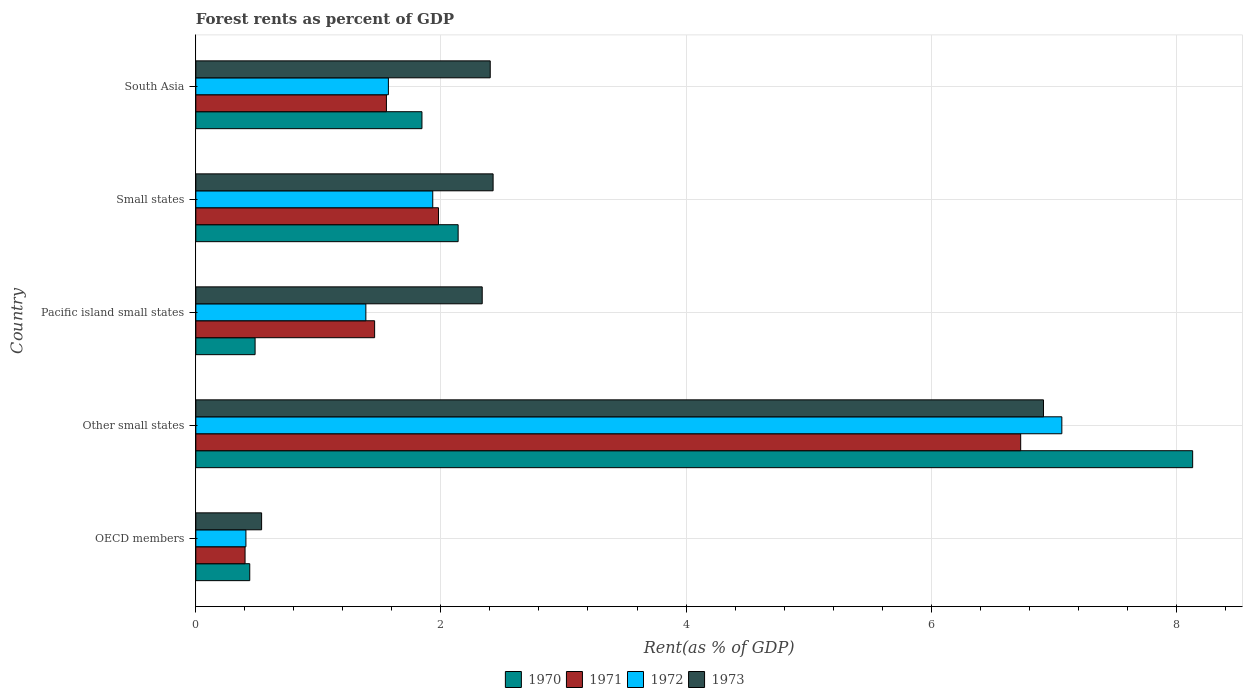How many groups of bars are there?
Your answer should be compact. 5. How many bars are there on the 1st tick from the top?
Make the answer very short. 4. How many bars are there on the 4th tick from the bottom?
Your answer should be compact. 4. What is the label of the 4th group of bars from the top?
Provide a short and direct response. Other small states. What is the forest rent in 1971 in South Asia?
Provide a short and direct response. 1.56. Across all countries, what is the maximum forest rent in 1970?
Your response must be concise. 8.13. Across all countries, what is the minimum forest rent in 1971?
Provide a short and direct response. 0.4. In which country was the forest rent in 1972 maximum?
Your answer should be compact. Other small states. What is the total forest rent in 1970 in the graph?
Make the answer very short. 13.04. What is the difference between the forest rent in 1970 in Other small states and that in Small states?
Make the answer very short. 5.99. What is the difference between the forest rent in 1971 in South Asia and the forest rent in 1970 in OECD members?
Your answer should be very brief. 1.12. What is the average forest rent in 1972 per country?
Provide a short and direct response. 2.47. What is the difference between the forest rent in 1971 and forest rent in 1972 in South Asia?
Your answer should be very brief. -0.02. What is the ratio of the forest rent in 1972 in Pacific island small states to that in South Asia?
Make the answer very short. 0.88. Is the forest rent in 1972 in Other small states less than that in South Asia?
Make the answer very short. No. What is the difference between the highest and the second highest forest rent in 1972?
Offer a terse response. 5.13. What is the difference between the highest and the lowest forest rent in 1972?
Give a very brief answer. 6.66. Is the sum of the forest rent in 1972 in Other small states and South Asia greater than the maximum forest rent in 1973 across all countries?
Your answer should be very brief. Yes. Is it the case that in every country, the sum of the forest rent in 1972 and forest rent in 1971 is greater than the sum of forest rent in 1973 and forest rent in 1970?
Offer a very short reply. No. What does the 4th bar from the top in South Asia represents?
Give a very brief answer. 1970. What does the 2nd bar from the bottom in South Asia represents?
Your response must be concise. 1971. What is the difference between two consecutive major ticks on the X-axis?
Provide a short and direct response. 2. Does the graph contain any zero values?
Offer a very short reply. No. Does the graph contain grids?
Give a very brief answer. Yes. How many legend labels are there?
Keep it short and to the point. 4. How are the legend labels stacked?
Provide a short and direct response. Horizontal. What is the title of the graph?
Provide a succinct answer. Forest rents as percent of GDP. What is the label or title of the X-axis?
Your answer should be compact. Rent(as % of GDP). What is the label or title of the Y-axis?
Give a very brief answer. Country. What is the Rent(as % of GDP) of 1970 in OECD members?
Your response must be concise. 0.44. What is the Rent(as % of GDP) in 1971 in OECD members?
Your answer should be compact. 0.4. What is the Rent(as % of GDP) of 1972 in OECD members?
Provide a succinct answer. 0.41. What is the Rent(as % of GDP) in 1973 in OECD members?
Provide a succinct answer. 0.54. What is the Rent(as % of GDP) of 1970 in Other small states?
Keep it short and to the point. 8.13. What is the Rent(as % of GDP) in 1971 in Other small states?
Your answer should be compact. 6.73. What is the Rent(as % of GDP) in 1972 in Other small states?
Offer a very short reply. 7.07. What is the Rent(as % of GDP) of 1973 in Other small states?
Offer a terse response. 6.92. What is the Rent(as % of GDP) in 1970 in Pacific island small states?
Offer a terse response. 0.48. What is the Rent(as % of GDP) in 1971 in Pacific island small states?
Your answer should be very brief. 1.46. What is the Rent(as % of GDP) in 1972 in Pacific island small states?
Ensure brevity in your answer.  1.39. What is the Rent(as % of GDP) of 1973 in Pacific island small states?
Your answer should be very brief. 2.34. What is the Rent(as % of GDP) of 1970 in Small states?
Provide a short and direct response. 2.14. What is the Rent(as % of GDP) of 1971 in Small states?
Ensure brevity in your answer.  1.98. What is the Rent(as % of GDP) of 1972 in Small states?
Keep it short and to the point. 1.93. What is the Rent(as % of GDP) of 1973 in Small states?
Your answer should be very brief. 2.43. What is the Rent(as % of GDP) of 1970 in South Asia?
Offer a terse response. 1.85. What is the Rent(as % of GDP) of 1971 in South Asia?
Offer a terse response. 1.56. What is the Rent(as % of GDP) in 1972 in South Asia?
Your answer should be very brief. 1.57. What is the Rent(as % of GDP) in 1973 in South Asia?
Your answer should be compact. 2.4. Across all countries, what is the maximum Rent(as % of GDP) of 1970?
Your answer should be very brief. 8.13. Across all countries, what is the maximum Rent(as % of GDP) of 1971?
Make the answer very short. 6.73. Across all countries, what is the maximum Rent(as % of GDP) in 1972?
Make the answer very short. 7.07. Across all countries, what is the maximum Rent(as % of GDP) in 1973?
Your answer should be compact. 6.92. Across all countries, what is the minimum Rent(as % of GDP) in 1970?
Offer a very short reply. 0.44. Across all countries, what is the minimum Rent(as % of GDP) of 1971?
Give a very brief answer. 0.4. Across all countries, what is the minimum Rent(as % of GDP) of 1972?
Your response must be concise. 0.41. Across all countries, what is the minimum Rent(as % of GDP) in 1973?
Offer a very short reply. 0.54. What is the total Rent(as % of GDP) in 1970 in the graph?
Provide a succinct answer. 13.04. What is the total Rent(as % of GDP) of 1971 in the graph?
Offer a terse response. 12.13. What is the total Rent(as % of GDP) in 1972 in the graph?
Make the answer very short. 12.37. What is the total Rent(as % of GDP) in 1973 in the graph?
Keep it short and to the point. 14.62. What is the difference between the Rent(as % of GDP) of 1970 in OECD members and that in Other small states?
Your answer should be very brief. -7.69. What is the difference between the Rent(as % of GDP) of 1971 in OECD members and that in Other small states?
Provide a short and direct response. -6.33. What is the difference between the Rent(as % of GDP) of 1972 in OECD members and that in Other small states?
Offer a terse response. -6.66. What is the difference between the Rent(as % of GDP) of 1973 in OECD members and that in Other small states?
Keep it short and to the point. -6.38. What is the difference between the Rent(as % of GDP) of 1970 in OECD members and that in Pacific island small states?
Offer a terse response. -0.04. What is the difference between the Rent(as % of GDP) in 1971 in OECD members and that in Pacific island small states?
Keep it short and to the point. -1.06. What is the difference between the Rent(as % of GDP) in 1972 in OECD members and that in Pacific island small states?
Provide a succinct answer. -0.98. What is the difference between the Rent(as % of GDP) of 1973 in OECD members and that in Pacific island small states?
Your answer should be very brief. -1.8. What is the difference between the Rent(as % of GDP) of 1970 in OECD members and that in Small states?
Your response must be concise. -1.7. What is the difference between the Rent(as % of GDP) in 1971 in OECD members and that in Small states?
Offer a terse response. -1.58. What is the difference between the Rent(as % of GDP) in 1972 in OECD members and that in Small states?
Your answer should be very brief. -1.52. What is the difference between the Rent(as % of GDP) of 1973 in OECD members and that in Small states?
Offer a terse response. -1.89. What is the difference between the Rent(as % of GDP) of 1970 in OECD members and that in South Asia?
Provide a short and direct response. -1.41. What is the difference between the Rent(as % of GDP) of 1971 in OECD members and that in South Asia?
Offer a very short reply. -1.15. What is the difference between the Rent(as % of GDP) in 1972 in OECD members and that in South Asia?
Offer a terse response. -1.16. What is the difference between the Rent(as % of GDP) in 1973 in OECD members and that in South Asia?
Your answer should be very brief. -1.87. What is the difference between the Rent(as % of GDP) of 1970 in Other small states and that in Pacific island small states?
Your response must be concise. 7.65. What is the difference between the Rent(as % of GDP) of 1971 in Other small states and that in Pacific island small states?
Your answer should be very brief. 5.27. What is the difference between the Rent(as % of GDP) in 1972 in Other small states and that in Pacific island small states?
Provide a short and direct response. 5.68. What is the difference between the Rent(as % of GDP) in 1973 in Other small states and that in Pacific island small states?
Provide a short and direct response. 4.58. What is the difference between the Rent(as % of GDP) of 1970 in Other small states and that in Small states?
Keep it short and to the point. 5.99. What is the difference between the Rent(as % of GDP) of 1971 in Other small states and that in Small states?
Give a very brief answer. 4.75. What is the difference between the Rent(as % of GDP) in 1972 in Other small states and that in Small states?
Keep it short and to the point. 5.13. What is the difference between the Rent(as % of GDP) of 1973 in Other small states and that in Small states?
Give a very brief answer. 4.49. What is the difference between the Rent(as % of GDP) of 1970 in Other small states and that in South Asia?
Your answer should be very brief. 6.29. What is the difference between the Rent(as % of GDP) of 1971 in Other small states and that in South Asia?
Offer a terse response. 5.18. What is the difference between the Rent(as % of GDP) of 1972 in Other small states and that in South Asia?
Make the answer very short. 5.5. What is the difference between the Rent(as % of GDP) of 1973 in Other small states and that in South Asia?
Ensure brevity in your answer.  4.51. What is the difference between the Rent(as % of GDP) of 1970 in Pacific island small states and that in Small states?
Make the answer very short. -1.66. What is the difference between the Rent(as % of GDP) of 1971 in Pacific island small states and that in Small states?
Give a very brief answer. -0.52. What is the difference between the Rent(as % of GDP) of 1972 in Pacific island small states and that in Small states?
Provide a succinct answer. -0.55. What is the difference between the Rent(as % of GDP) in 1973 in Pacific island small states and that in Small states?
Ensure brevity in your answer.  -0.09. What is the difference between the Rent(as % of GDP) of 1970 in Pacific island small states and that in South Asia?
Keep it short and to the point. -1.36. What is the difference between the Rent(as % of GDP) of 1971 in Pacific island small states and that in South Asia?
Your answer should be very brief. -0.1. What is the difference between the Rent(as % of GDP) of 1972 in Pacific island small states and that in South Asia?
Provide a succinct answer. -0.18. What is the difference between the Rent(as % of GDP) of 1973 in Pacific island small states and that in South Asia?
Your response must be concise. -0.07. What is the difference between the Rent(as % of GDP) of 1970 in Small states and that in South Asia?
Make the answer very short. 0.3. What is the difference between the Rent(as % of GDP) of 1971 in Small states and that in South Asia?
Provide a short and direct response. 0.42. What is the difference between the Rent(as % of GDP) in 1972 in Small states and that in South Asia?
Your answer should be compact. 0.36. What is the difference between the Rent(as % of GDP) of 1973 in Small states and that in South Asia?
Your response must be concise. 0.02. What is the difference between the Rent(as % of GDP) in 1970 in OECD members and the Rent(as % of GDP) in 1971 in Other small states?
Provide a short and direct response. -6.29. What is the difference between the Rent(as % of GDP) in 1970 in OECD members and the Rent(as % of GDP) in 1972 in Other small states?
Keep it short and to the point. -6.63. What is the difference between the Rent(as % of GDP) of 1970 in OECD members and the Rent(as % of GDP) of 1973 in Other small states?
Provide a succinct answer. -6.48. What is the difference between the Rent(as % of GDP) in 1971 in OECD members and the Rent(as % of GDP) in 1972 in Other small states?
Your answer should be compact. -6.67. What is the difference between the Rent(as % of GDP) of 1971 in OECD members and the Rent(as % of GDP) of 1973 in Other small states?
Give a very brief answer. -6.52. What is the difference between the Rent(as % of GDP) of 1972 in OECD members and the Rent(as % of GDP) of 1973 in Other small states?
Your response must be concise. -6.51. What is the difference between the Rent(as % of GDP) of 1970 in OECD members and the Rent(as % of GDP) of 1971 in Pacific island small states?
Provide a succinct answer. -1.02. What is the difference between the Rent(as % of GDP) of 1970 in OECD members and the Rent(as % of GDP) of 1972 in Pacific island small states?
Your response must be concise. -0.95. What is the difference between the Rent(as % of GDP) in 1970 in OECD members and the Rent(as % of GDP) in 1973 in Pacific island small states?
Offer a very short reply. -1.9. What is the difference between the Rent(as % of GDP) in 1971 in OECD members and the Rent(as % of GDP) in 1972 in Pacific island small states?
Make the answer very short. -0.99. What is the difference between the Rent(as % of GDP) of 1971 in OECD members and the Rent(as % of GDP) of 1973 in Pacific island small states?
Provide a succinct answer. -1.94. What is the difference between the Rent(as % of GDP) of 1972 in OECD members and the Rent(as % of GDP) of 1973 in Pacific island small states?
Provide a short and direct response. -1.93. What is the difference between the Rent(as % of GDP) in 1970 in OECD members and the Rent(as % of GDP) in 1971 in Small states?
Keep it short and to the point. -1.54. What is the difference between the Rent(as % of GDP) of 1970 in OECD members and the Rent(as % of GDP) of 1972 in Small states?
Your answer should be very brief. -1.49. What is the difference between the Rent(as % of GDP) of 1970 in OECD members and the Rent(as % of GDP) of 1973 in Small states?
Give a very brief answer. -1.99. What is the difference between the Rent(as % of GDP) of 1971 in OECD members and the Rent(as % of GDP) of 1972 in Small states?
Your answer should be very brief. -1.53. What is the difference between the Rent(as % of GDP) in 1971 in OECD members and the Rent(as % of GDP) in 1973 in Small states?
Provide a succinct answer. -2.02. What is the difference between the Rent(as % of GDP) of 1972 in OECD members and the Rent(as % of GDP) of 1973 in Small states?
Keep it short and to the point. -2.02. What is the difference between the Rent(as % of GDP) of 1970 in OECD members and the Rent(as % of GDP) of 1971 in South Asia?
Keep it short and to the point. -1.12. What is the difference between the Rent(as % of GDP) in 1970 in OECD members and the Rent(as % of GDP) in 1972 in South Asia?
Give a very brief answer. -1.13. What is the difference between the Rent(as % of GDP) in 1970 in OECD members and the Rent(as % of GDP) in 1973 in South Asia?
Provide a short and direct response. -1.96. What is the difference between the Rent(as % of GDP) of 1971 in OECD members and the Rent(as % of GDP) of 1972 in South Asia?
Offer a terse response. -1.17. What is the difference between the Rent(as % of GDP) of 1971 in OECD members and the Rent(as % of GDP) of 1973 in South Asia?
Keep it short and to the point. -2. What is the difference between the Rent(as % of GDP) of 1972 in OECD members and the Rent(as % of GDP) of 1973 in South Asia?
Give a very brief answer. -1.99. What is the difference between the Rent(as % of GDP) in 1970 in Other small states and the Rent(as % of GDP) in 1971 in Pacific island small states?
Your response must be concise. 6.68. What is the difference between the Rent(as % of GDP) of 1970 in Other small states and the Rent(as % of GDP) of 1972 in Pacific island small states?
Offer a terse response. 6.75. What is the difference between the Rent(as % of GDP) in 1970 in Other small states and the Rent(as % of GDP) in 1973 in Pacific island small states?
Your answer should be compact. 5.8. What is the difference between the Rent(as % of GDP) in 1971 in Other small states and the Rent(as % of GDP) in 1972 in Pacific island small states?
Ensure brevity in your answer.  5.34. What is the difference between the Rent(as % of GDP) in 1971 in Other small states and the Rent(as % of GDP) in 1973 in Pacific island small states?
Your response must be concise. 4.39. What is the difference between the Rent(as % of GDP) of 1972 in Other small states and the Rent(as % of GDP) of 1973 in Pacific island small states?
Your answer should be compact. 4.73. What is the difference between the Rent(as % of GDP) in 1970 in Other small states and the Rent(as % of GDP) in 1971 in Small states?
Offer a terse response. 6.15. What is the difference between the Rent(as % of GDP) of 1970 in Other small states and the Rent(as % of GDP) of 1972 in Small states?
Your answer should be very brief. 6.2. What is the difference between the Rent(as % of GDP) in 1970 in Other small states and the Rent(as % of GDP) in 1973 in Small states?
Give a very brief answer. 5.71. What is the difference between the Rent(as % of GDP) in 1971 in Other small states and the Rent(as % of GDP) in 1972 in Small states?
Provide a succinct answer. 4.8. What is the difference between the Rent(as % of GDP) of 1971 in Other small states and the Rent(as % of GDP) of 1973 in Small states?
Give a very brief answer. 4.31. What is the difference between the Rent(as % of GDP) in 1972 in Other small states and the Rent(as % of GDP) in 1973 in Small states?
Make the answer very short. 4.64. What is the difference between the Rent(as % of GDP) in 1970 in Other small states and the Rent(as % of GDP) in 1971 in South Asia?
Give a very brief answer. 6.58. What is the difference between the Rent(as % of GDP) in 1970 in Other small states and the Rent(as % of GDP) in 1972 in South Asia?
Keep it short and to the point. 6.56. What is the difference between the Rent(as % of GDP) of 1970 in Other small states and the Rent(as % of GDP) of 1973 in South Asia?
Your answer should be very brief. 5.73. What is the difference between the Rent(as % of GDP) in 1971 in Other small states and the Rent(as % of GDP) in 1972 in South Asia?
Your answer should be very brief. 5.16. What is the difference between the Rent(as % of GDP) of 1971 in Other small states and the Rent(as % of GDP) of 1973 in South Asia?
Keep it short and to the point. 4.33. What is the difference between the Rent(as % of GDP) in 1972 in Other small states and the Rent(as % of GDP) in 1973 in South Asia?
Provide a short and direct response. 4.66. What is the difference between the Rent(as % of GDP) in 1970 in Pacific island small states and the Rent(as % of GDP) in 1971 in Small states?
Give a very brief answer. -1.5. What is the difference between the Rent(as % of GDP) in 1970 in Pacific island small states and the Rent(as % of GDP) in 1972 in Small states?
Keep it short and to the point. -1.45. What is the difference between the Rent(as % of GDP) of 1970 in Pacific island small states and the Rent(as % of GDP) of 1973 in Small states?
Provide a short and direct response. -1.94. What is the difference between the Rent(as % of GDP) in 1971 in Pacific island small states and the Rent(as % of GDP) in 1972 in Small states?
Provide a succinct answer. -0.47. What is the difference between the Rent(as % of GDP) of 1971 in Pacific island small states and the Rent(as % of GDP) of 1973 in Small states?
Offer a terse response. -0.97. What is the difference between the Rent(as % of GDP) in 1972 in Pacific island small states and the Rent(as % of GDP) in 1973 in Small states?
Your response must be concise. -1.04. What is the difference between the Rent(as % of GDP) in 1970 in Pacific island small states and the Rent(as % of GDP) in 1971 in South Asia?
Offer a very short reply. -1.07. What is the difference between the Rent(as % of GDP) in 1970 in Pacific island small states and the Rent(as % of GDP) in 1972 in South Asia?
Offer a very short reply. -1.09. What is the difference between the Rent(as % of GDP) in 1970 in Pacific island small states and the Rent(as % of GDP) in 1973 in South Asia?
Provide a short and direct response. -1.92. What is the difference between the Rent(as % of GDP) of 1971 in Pacific island small states and the Rent(as % of GDP) of 1972 in South Asia?
Your answer should be very brief. -0.11. What is the difference between the Rent(as % of GDP) in 1971 in Pacific island small states and the Rent(as % of GDP) in 1973 in South Asia?
Give a very brief answer. -0.94. What is the difference between the Rent(as % of GDP) of 1972 in Pacific island small states and the Rent(as % of GDP) of 1973 in South Asia?
Give a very brief answer. -1.01. What is the difference between the Rent(as % of GDP) in 1970 in Small states and the Rent(as % of GDP) in 1971 in South Asia?
Your answer should be very brief. 0.59. What is the difference between the Rent(as % of GDP) of 1970 in Small states and the Rent(as % of GDP) of 1972 in South Asia?
Make the answer very short. 0.57. What is the difference between the Rent(as % of GDP) in 1970 in Small states and the Rent(as % of GDP) in 1973 in South Asia?
Provide a succinct answer. -0.26. What is the difference between the Rent(as % of GDP) in 1971 in Small states and the Rent(as % of GDP) in 1972 in South Asia?
Your answer should be compact. 0.41. What is the difference between the Rent(as % of GDP) in 1971 in Small states and the Rent(as % of GDP) in 1973 in South Asia?
Offer a terse response. -0.42. What is the difference between the Rent(as % of GDP) in 1972 in Small states and the Rent(as % of GDP) in 1973 in South Asia?
Provide a short and direct response. -0.47. What is the average Rent(as % of GDP) in 1970 per country?
Offer a terse response. 2.61. What is the average Rent(as % of GDP) in 1971 per country?
Your answer should be very brief. 2.43. What is the average Rent(as % of GDP) of 1972 per country?
Provide a succinct answer. 2.47. What is the average Rent(as % of GDP) of 1973 per country?
Offer a very short reply. 2.92. What is the difference between the Rent(as % of GDP) in 1970 and Rent(as % of GDP) in 1971 in OECD members?
Your answer should be very brief. 0.04. What is the difference between the Rent(as % of GDP) of 1970 and Rent(as % of GDP) of 1972 in OECD members?
Your answer should be compact. 0.03. What is the difference between the Rent(as % of GDP) in 1970 and Rent(as % of GDP) in 1973 in OECD members?
Your answer should be compact. -0.1. What is the difference between the Rent(as % of GDP) in 1971 and Rent(as % of GDP) in 1972 in OECD members?
Keep it short and to the point. -0.01. What is the difference between the Rent(as % of GDP) of 1971 and Rent(as % of GDP) of 1973 in OECD members?
Provide a short and direct response. -0.14. What is the difference between the Rent(as % of GDP) in 1972 and Rent(as % of GDP) in 1973 in OECD members?
Your response must be concise. -0.13. What is the difference between the Rent(as % of GDP) of 1970 and Rent(as % of GDP) of 1971 in Other small states?
Your answer should be compact. 1.4. What is the difference between the Rent(as % of GDP) of 1970 and Rent(as % of GDP) of 1972 in Other small states?
Your answer should be compact. 1.07. What is the difference between the Rent(as % of GDP) in 1970 and Rent(as % of GDP) in 1973 in Other small states?
Provide a short and direct response. 1.22. What is the difference between the Rent(as % of GDP) of 1971 and Rent(as % of GDP) of 1972 in Other small states?
Your answer should be compact. -0.34. What is the difference between the Rent(as % of GDP) in 1971 and Rent(as % of GDP) in 1973 in Other small states?
Make the answer very short. -0.19. What is the difference between the Rent(as % of GDP) of 1972 and Rent(as % of GDP) of 1973 in Other small states?
Give a very brief answer. 0.15. What is the difference between the Rent(as % of GDP) in 1970 and Rent(as % of GDP) in 1971 in Pacific island small states?
Ensure brevity in your answer.  -0.98. What is the difference between the Rent(as % of GDP) of 1970 and Rent(as % of GDP) of 1972 in Pacific island small states?
Offer a terse response. -0.9. What is the difference between the Rent(as % of GDP) in 1970 and Rent(as % of GDP) in 1973 in Pacific island small states?
Offer a very short reply. -1.85. What is the difference between the Rent(as % of GDP) of 1971 and Rent(as % of GDP) of 1972 in Pacific island small states?
Your answer should be compact. 0.07. What is the difference between the Rent(as % of GDP) of 1971 and Rent(as % of GDP) of 1973 in Pacific island small states?
Keep it short and to the point. -0.88. What is the difference between the Rent(as % of GDP) in 1972 and Rent(as % of GDP) in 1973 in Pacific island small states?
Keep it short and to the point. -0.95. What is the difference between the Rent(as % of GDP) of 1970 and Rent(as % of GDP) of 1971 in Small states?
Your answer should be compact. 0.16. What is the difference between the Rent(as % of GDP) in 1970 and Rent(as % of GDP) in 1972 in Small states?
Ensure brevity in your answer.  0.21. What is the difference between the Rent(as % of GDP) in 1970 and Rent(as % of GDP) in 1973 in Small states?
Offer a very short reply. -0.29. What is the difference between the Rent(as % of GDP) in 1971 and Rent(as % of GDP) in 1972 in Small states?
Ensure brevity in your answer.  0.05. What is the difference between the Rent(as % of GDP) of 1971 and Rent(as % of GDP) of 1973 in Small states?
Provide a succinct answer. -0.45. What is the difference between the Rent(as % of GDP) in 1972 and Rent(as % of GDP) in 1973 in Small states?
Keep it short and to the point. -0.49. What is the difference between the Rent(as % of GDP) of 1970 and Rent(as % of GDP) of 1971 in South Asia?
Offer a terse response. 0.29. What is the difference between the Rent(as % of GDP) of 1970 and Rent(as % of GDP) of 1972 in South Asia?
Keep it short and to the point. 0.27. What is the difference between the Rent(as % of GDP) of 1970 and Rent(as % of GDP) of 1973 in South Asia?
Your response must be concise. -0.56. What is the difference between the Rent(as % of GDP) in 1971 and Rent(as % of GDP) in 1972 in South Asia?
Ensure brevity in your answer.  -0.02. What is the difference between the Rent(as % of GDP) of 1971 and Rent(as % of GDP) of 1973 in South Asia?
Ensure brevity in your answer.  -0.85. What is the difference between the Rent(as % of GDP) of 1972 and Rent(as % of GDP) of 1973 in South Asia?
Make the answer very short. -0.83. What is the ratio of the Rent(as % of GDP) in 1970 in OECD members to that in Other small states?
Ensure brevity in your answer.  0.05. What is the ratio of the Rent(as % of GDP) in 1971 in OECD members to that in Other small states?
Make the answer very short. 0.06. What is the ratio of the Rent(as % of GDP) of 1972 in OECD members to that in Other small states?
Ensure brevity in your answer.  0.06. What is the ratio of the Rent(as % of GDP) of 1973 in OECD members to that in Other small states?
Your response must be concise. 0.08. What is the ratio of the Rent(as % of GDP) of 1970 in OECD members to that in Pacific island small states?
Ensure brevity in your answer.  0.91. What is the ratio of the Rent(as % of GDP) of 1971 in OECD members to that in Pacific island small states?
Provide a short and direct response. 0.28. What is the ratio of the Rent(as % of GDP) in 1972 in OECD members to that in Pacific island small states?
Your answer should be very brief. 0.29. What is the ratio of the Rent(as % of GDP) in 1973 in OECD members to that in Pacific island small states?
Your answer should be very brief. 0.23. What is the ratio of the Rent(as % of GDP) of 1970 in OECD members to that in Small states?
Your response must be concise. 0.21. What is the ratio of the Rent(as % of GDP) in 1971 in OECD members to that in Small states?
Keep it short and to the point. 0.2. What is the ratio of the Rent(as % of GDP) of 1972 in OECD members to that in Small states?
Make the answer very short. 0.21. What is the ratio of the Rent(as % of GDP) in 1973 in OECD members to that in Small states?
Offer a very short reply. 0.22. What is the ratio of the Rent(as % of GDP) of 1970 in OECD members to that in South Asia?
Your answer should be compact. 0.24. What is the ratio of the Rent(as % of GDP) in 1971 in OECD members to that in South Asia?
Your response must be concise. 0.26. What is the ratio of the Rent(as % of GDP) of 1972 in OECD members to that in South Asia?
Give a very brief answer. 0.26. What is the ratio of the Rent(as % of GDP) of 1973 in OECD members to that in South Asia?
Your answer should be compact. 0.22. What is the ratio of the Rent(as % of GDP) of 1970 in Other small states to that in Pacific island small states?
Keep it short and to the point. 16.82. What is the ratio of the Rent(as % of GDP) of 1971 in Other small states to that in Pacific island small states?
Keep it short and to the point. 4.61. What is the ratio of the Rent(as % of GDP) of 1972 in Other small states to that in Pacific island small states?
Make the answer very short. 5.09. What is the ratio of the Rent(as % of GDP) of 1973 in Other small states to that in Pacific island small states?
Offer a very short reply. 2.96. What is the ratio of the Rent(as % of GDP) of 1970 in Other small states to that in Small states?
Offer a very short reply. 3.8. What is the ratio of the Rent(as % of GDP) in 1971 in Other small states to that in Small states?
Provide a short and direct response. 3.4. What is the ratio of the Rent(as % of GDP) of 1972 in Other small states to that in Small states?
Offer a very short reply. 3.66. What is the ratio of the Rent(as % of GDP) in 1973 in Other small states to that in Small states?
Your answer should be compact. 2.85. What is the ratio of the Rent(as % of GDP) of 1970 in Other small states to that in South Asia?
Provide a short and direct response. 4.41. What is the ratio of the Rent(as % of GDP) of 1971 in Other small states to that in South Asia?
Ensure brevity in your answer.  4.33. What is the ratio of the Rent(as % of GDP) of 1972 in Other small states to that in South Asia?
Make the answer very short. 4.5. What is the ratio of the Rent(as % of GDP) in 1973 in Other small states to that in South Asia?
Provide a succinct answer. 2.88. What is the ratio of the Rent(as % of GDP) of 1970 in Pacific island small states to that in Small states?
Your answer should be compact. 0.23. What is the ratio of the Rent(as % of GDP) of 1971 in Pacific island small states to that in Small states?
Ensure brevity in your answer.  0.74. What is the ratio of the Rent(as % of GDP) of 1972 in Pacific island small states to that in Small states?
Give a very brief answer. 0.72. What is the ratio of the Rent(as % of GDP) of 1973 in Pacific island small states to that in Small states?
Your answer should be compact. 0.96. What is the ratio of the Rent(as % of GDP) in 1970 in Pacific island small states to that in South Asia?
Give a very brief answer. 0.26. What is the ratio of the Rent(as % of GDP) in 1971 in Pacific island small states to that in South Asia?
Keep it short and to the point. 0.94. What is the ratio of the Rent(as % of GDP) of 1972 in Pacific island small states to that in South Asia?
Your answer should be very brief. 0.88. What is the ratio of the Rent(as % of GDP) of 1973 in Pacific island small states to that in South Asia?
Provide a succinct answer. 0.97. What is the ratio of the Rent(as % of GDP) in 1970 in Small states to that in South Asia?
Ensure brevity in your answer.  1.16. What is the ratio of the Rent(as % of GDP) of 1971 in Small states to that in South Asia?
Provide a short and direct response. 1.27. What is the ratio of the Rent(as % of GDP) of 1972 in Small states to that in South Asia?
Ensure brevity in your answer.  1.23. What is the ratio of the Rent(as % of GDP) in 1973 in Small states to that in South Asia?
Provide a succinct answer. 1.01. What is the difference between the highest and the second highest Rent(as % of GDP) in 1970?
Keep it short and to the point. 5.99. What is the difference between the highest and the second highest Rent(as % of GDP) in 1971?
Your answer should be very brief. 4.75. What is the difference between the highest and the second highest Rent(as % of GDP) of 1972?
Ensure brevity in your answer.  5.13. What is the difference between the highest and the second highest Rent(as % of GDP) in 1973?
Make the answer very short. 4.49. What is the difference between the highest and the lowest Rent(as % of GDP) in 1970?
Give a very brief answer. 7.69. What is the difference between the highest and the lowest Rent(as % of GDP) in 1971?
Ensure brevity in your answer.  6.33. What is the difference between the highest and the lowest Rent(as % of GDP) in 1972?
Ensure brevity in your answer.  6.66. What is the difference between the highest and the lowest Rent(as % of GDP) of 1973?
Make the answer very short. 6.38. 